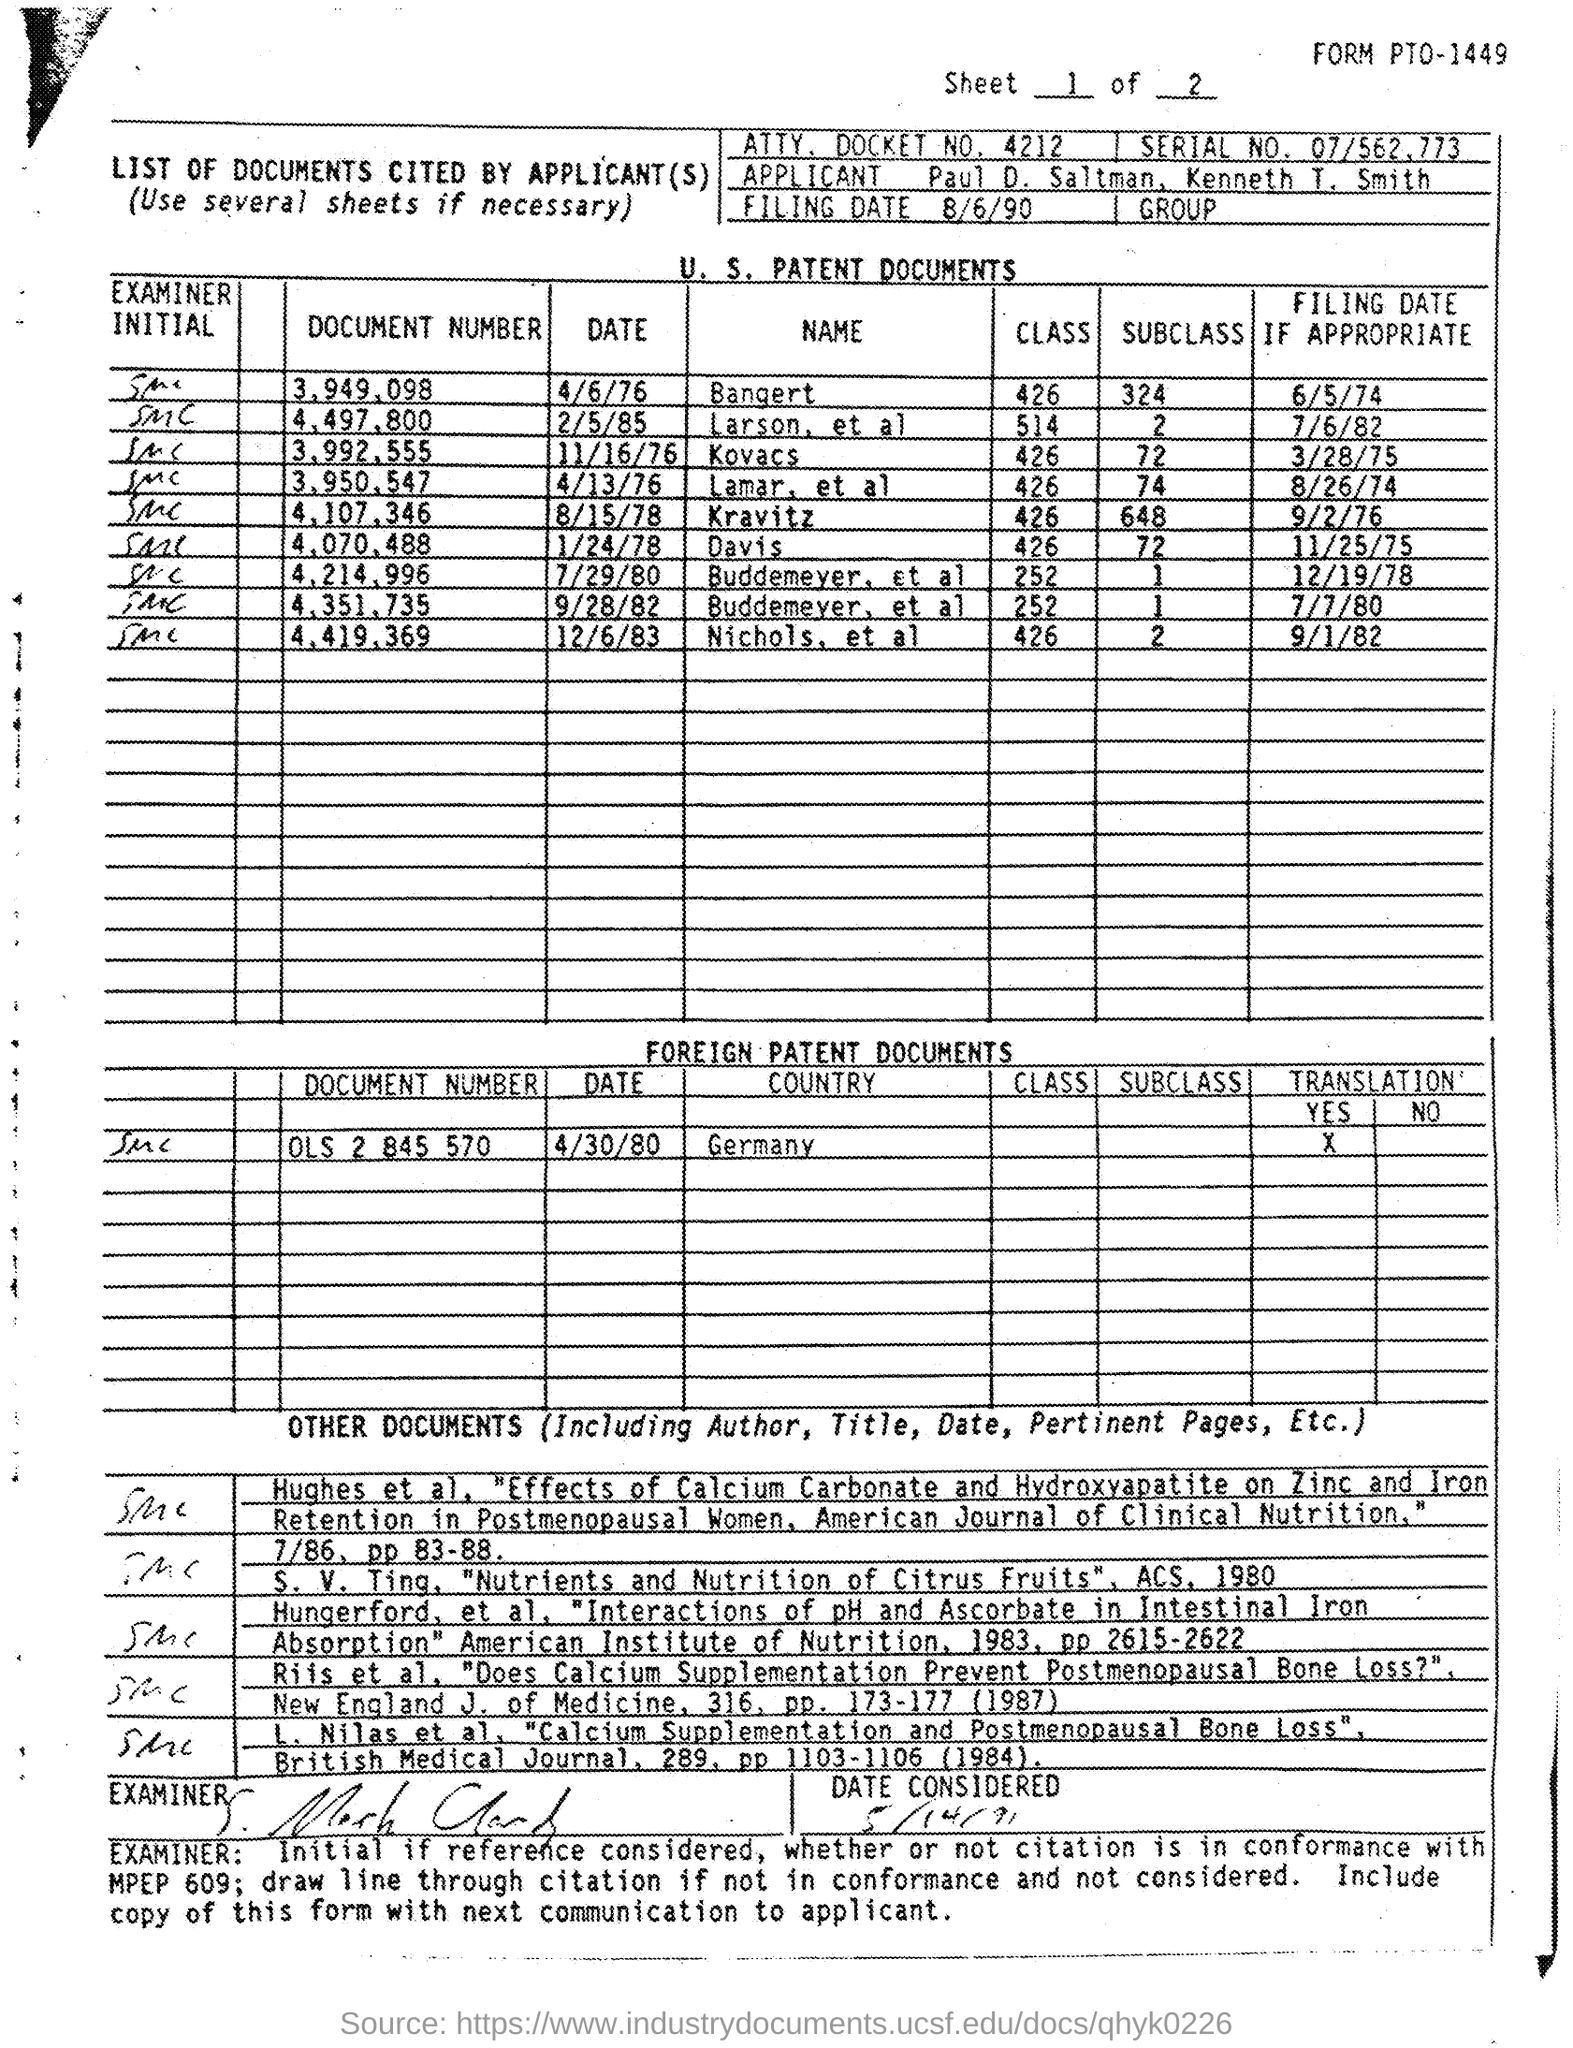Give some essential details in this illustration. The document number is German. On what date is document number 3.949.098? April 6th, 1976. 